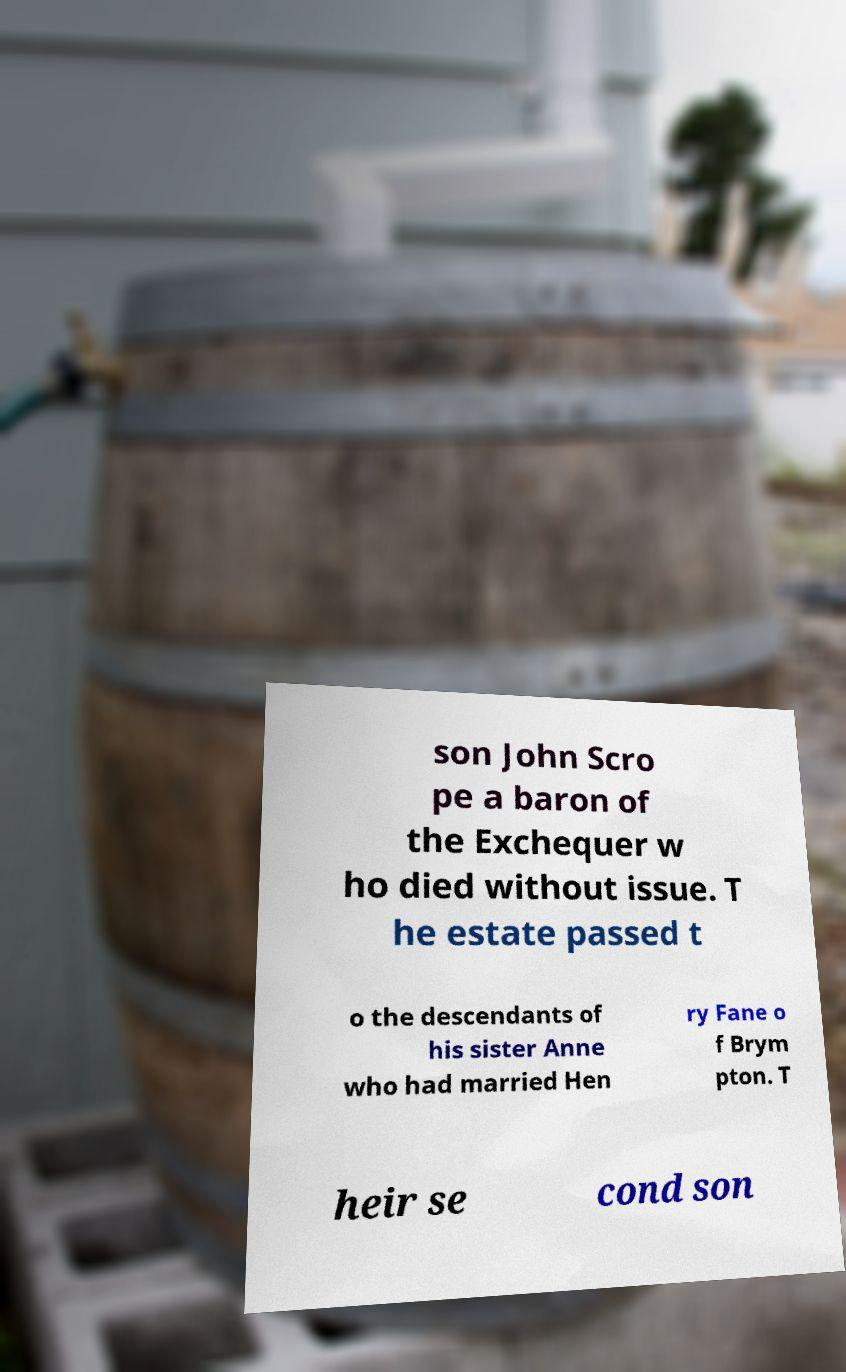For documentation purposes, I need the text within this image transcribed. Could you provide that? son John Scro pe a baron of the Exchequer w ho died without issue. T he estate passed t o the descendants of his sister Anne who had married Hen ry Fane o f Brym pton. T heir se cond son 